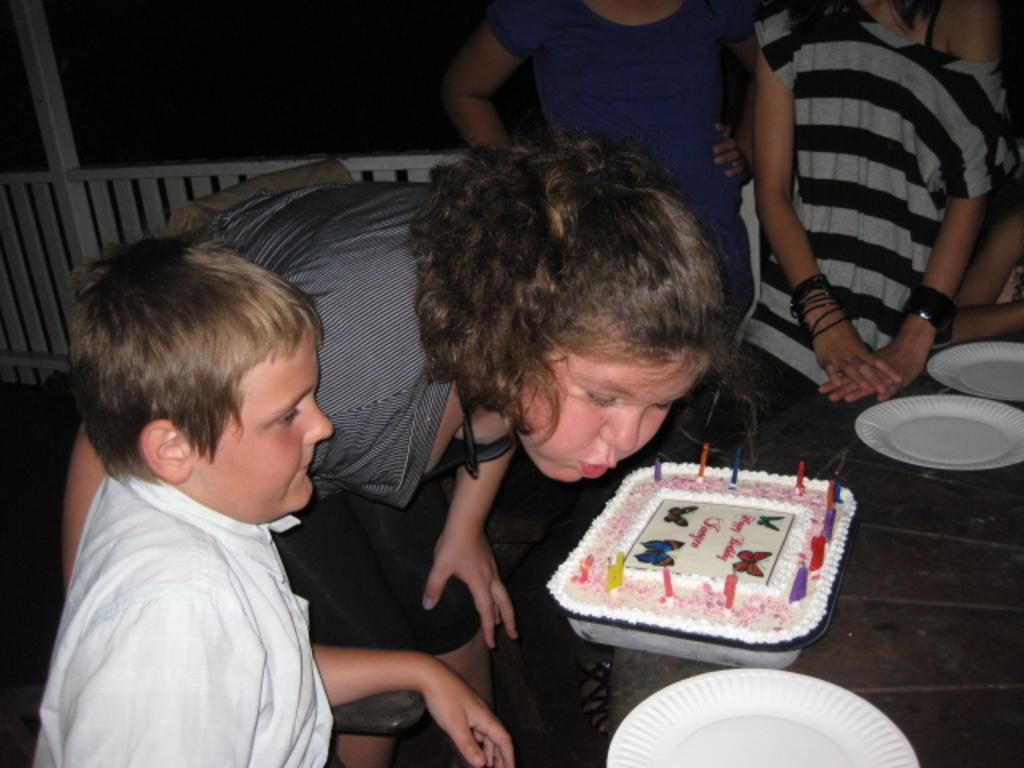How many people are present in the image? There are four people in the image, two standing and two sitting. What is on the table in the image? There are plates and a cake on the table. What can be seen in the background of the image? There is a fence visible in the background of the image. What type of produce can be seen in the jar on the table? There is no jar or produce present on the table in the image. 